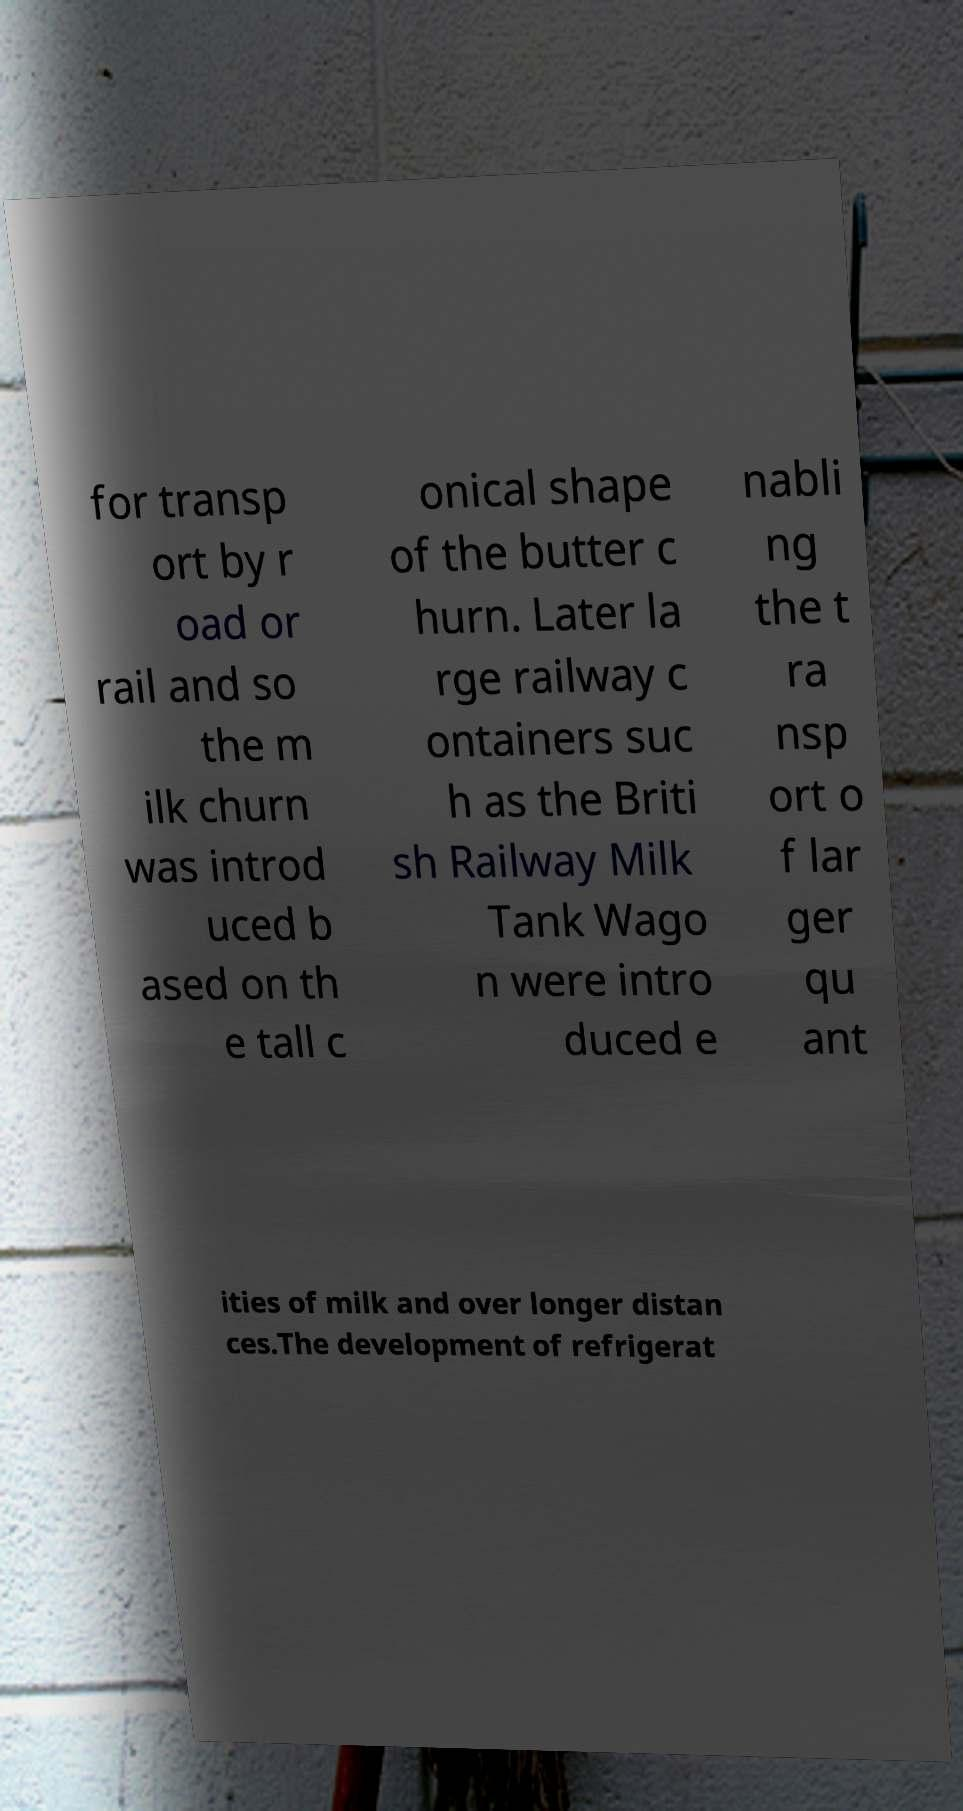What messages or text are displayed in this image? I need them in a readable, typed format. for transp ort by r oad or rail and so the m ilk churn was introd uced b ased on th e tall c onical shape of the butter c hurn. Later la rge railway c ontainers suc h as the Briti sh Railway Milk Tank Wago n were intro duced e nabli ng the t ra nsp ort o f lar ger qu ant ities of milk and over longer distan ces.The development of refrigerat 